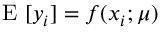Convert formula to latex. <formula><loc_0><loc_0><loc_500><loc_500>E [ y _ { i } ] = f ( x _ { i } ; \mu )</formula> 